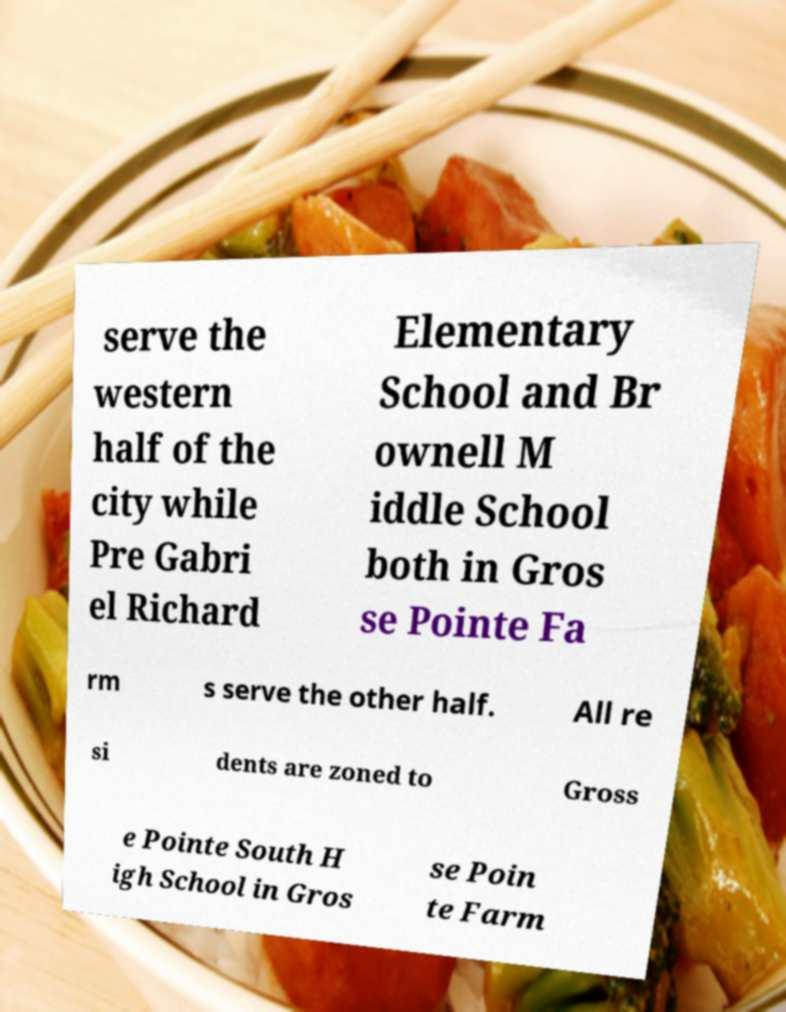Can you read and provide the text displayed in the image?This photo seems to have some interesting text. Can you extract and type it out for me? serve the western half of the city while Pre Gabri el Richard Elementary School and Br ownell M iddle School both in Gros se Pointe Fa rm s serve the other half. All re si dents are zoned to Gross e Pointe South H igh School in Gros se Poin te Farm 